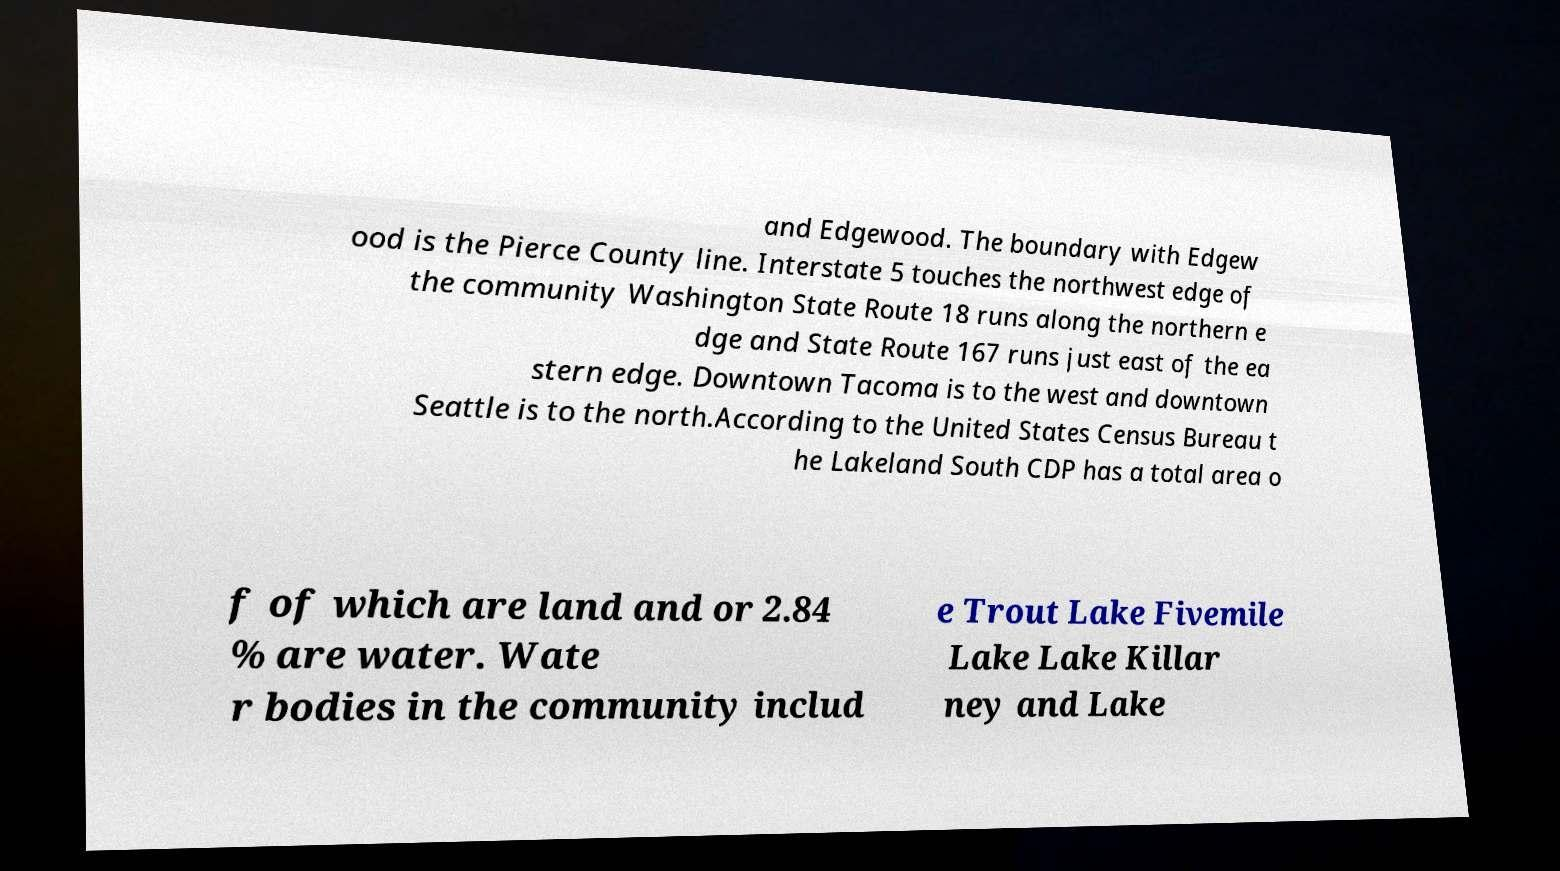I need the written content from this picture converted into text. Can you do that? and Edgewood. The boundary with Edgew ood is the Pierce County line. Interstate 5 touches the northwest edge of the community Washington State Route 18 runs along the northern e dge and State Route 167 runs just east of the ea stern edge. Downtown Tacoma is to the west and downtown Seattle is to the north.According to the United States Census Bureau t he Lakeland South CDP has a total area o f of which are land and or 2.84 % are water. Wate r bodies in the community includ e Trout Lake Fivemile Lake Lake Killar ney and Lake 